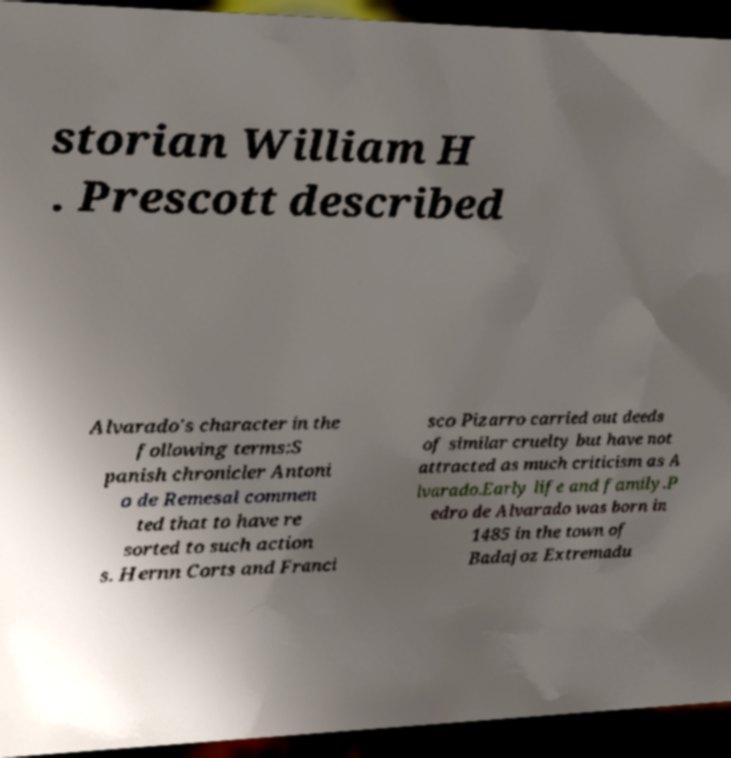For documentation purposes, I need the text within this image transcribed. Could you provide that? storian William H . Prescott described Alvarado's character in the following terms:S panish chronicler Antoni o de Remesal commen ted that to have re sorted to such action s. Hernn Corts and Franci sco Pizarro carried out deeds of similar cruelty but have not attracted as much criticism as A lvarado.Early life and family.P edro de Alvarado was born in 1485 in the town of Badajoz Extremadu 